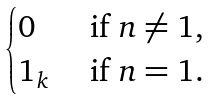<formula> <loc_0><loc_0><loc_500><loc_500>\begin{cases} 0 & \text { if } n \neq 1 , \\ 1 _ { k } & \text { if } n = 1 . \end{cases}</formula> 